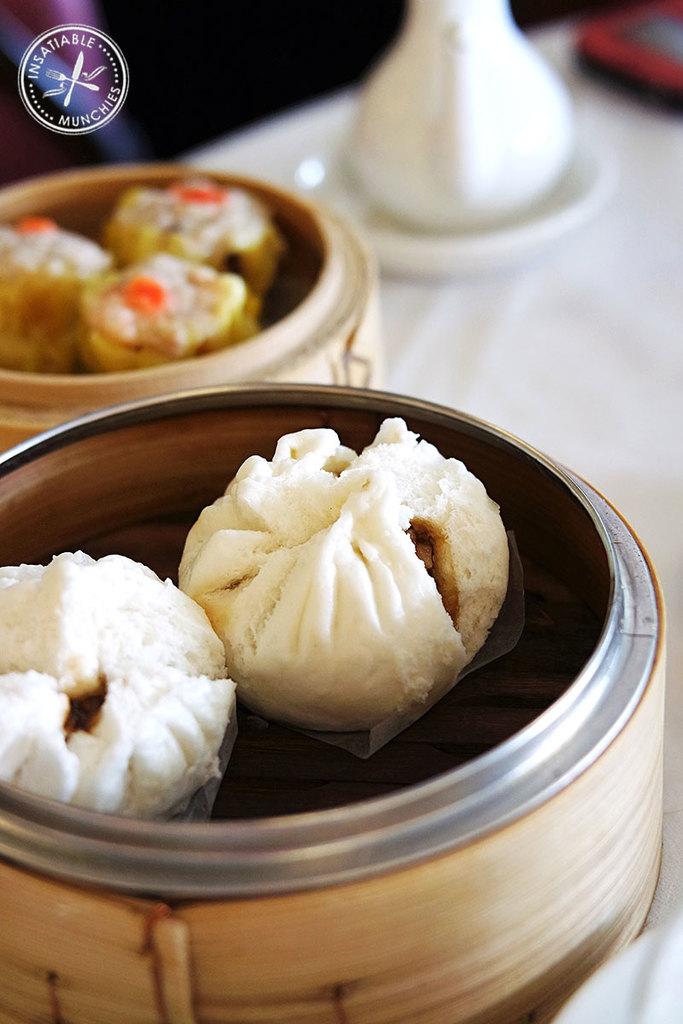This is insatiable what?
Provide a succinct answer. Munchies. 